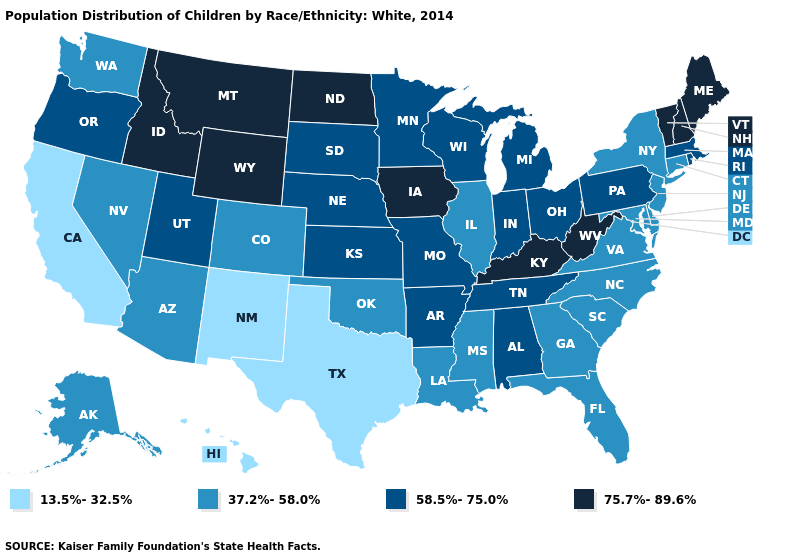Does North Carolina have the highest value in the USA?
Answer briefly. No. How many symbols are there in the legend?
Keep it brief. 4. Among the states that border New York , does Vermont have the highest value?
Be succinct. Yes. Name the states that have a value in the range 75.7%-89.6%?
Quick response, please. Idaho, Iowa, Kentucky, Maine, Montana, New Hampshire, North Dakota, Vermont, West Virginia, Wyoming. Does Texas have the lowest value in the USA?
Concise answer only. Yes. What is the value of Delaware?
Give a very brief answer. 37.2%-58.0%. Does Vermont have the same value as Alabama?
Write a very short answer. No. What is the lowest value in the West?
Be succinct. 13.5%-32.5%. What is the value of New Mexico?
Write a very short answer. 13.5%-32.5%. Does Washington have a lower value than Kentucky?
Concise answer only. Yes. Which states have the lowest value in the USA?
Short answer required. California, Hawaii, New Mexico, Texas. Which states have the lowest value in the USA?
Short answer required. California, Hawaii, New Mexico, Texas. Does California have the lowest value in the West?
Give a very brief answer. Yes. Name the states that have a value in the range 75.7%-89.6%?
Quick response, please. Idaho, Iowa, Kentucky, Maine, Montana, New Hampshire, North Dakota, Vermont, West Virginia, Wyoming. What is the lowest value in the West?
Keep it brief. 13.5%-32.5%. 